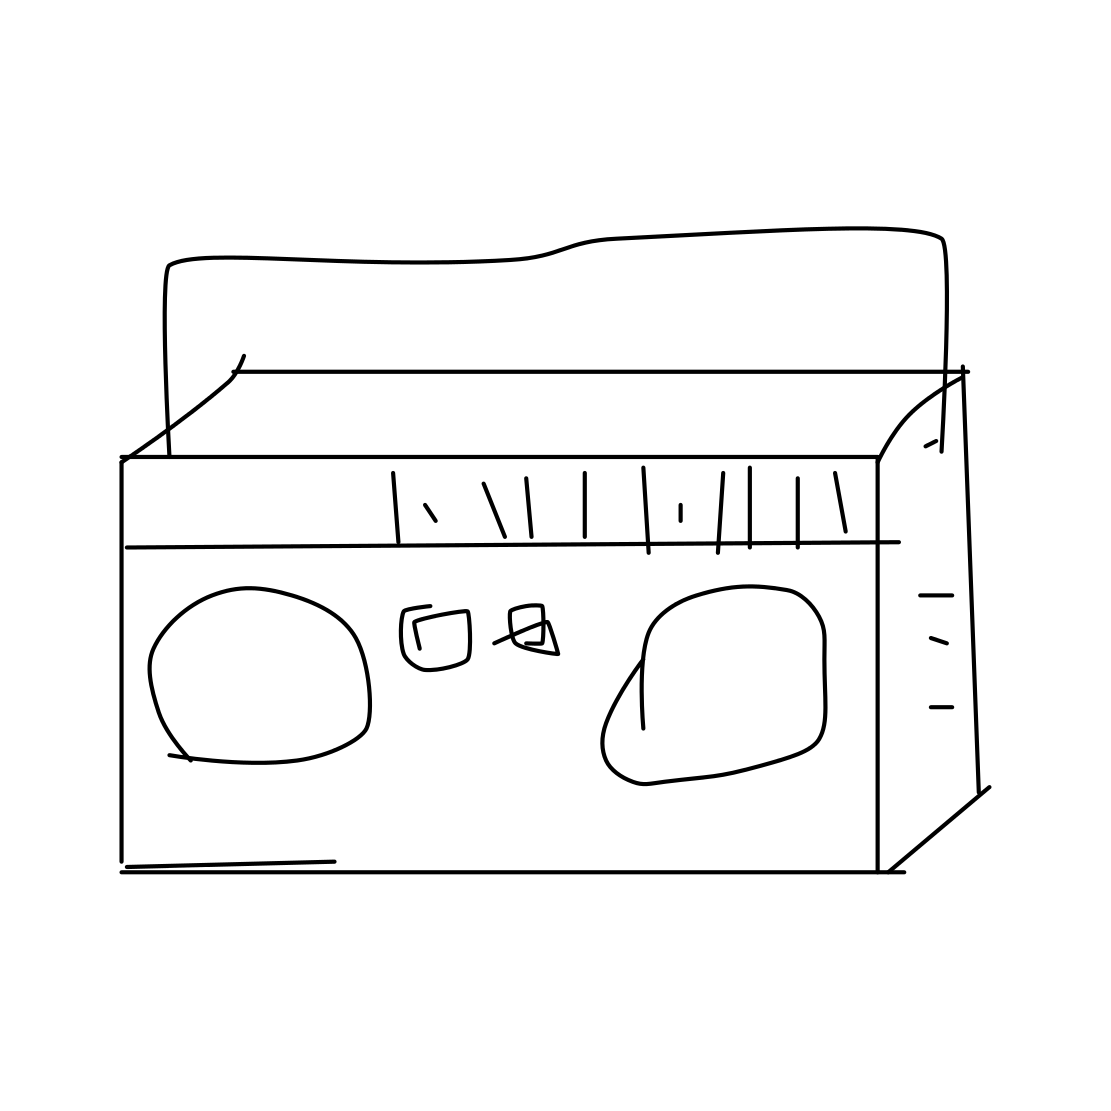In the scene, is an SUV in it? No, there isn't an SUV in the scene. The image shows a simple line drawing of a cassette tape, which is an analog magnetic tape recording format for audio recording and playback. 